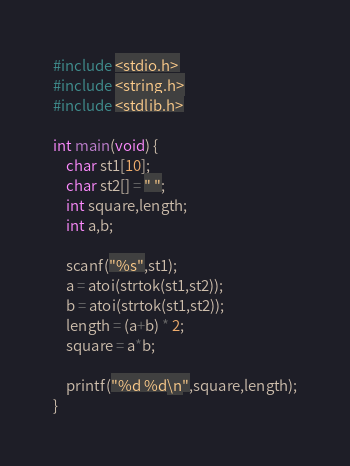Convert code to text. <code><loc_0><loc_0><loc_500><loc_500><_C_>#include <stdio.h>
#include <string.h>
#include <stdlib.h>

int main(void) {
	char st1[10];
	char st2[] = " ";
	int square,length;
	int a,b;
	
	scanf("%s",st1);
	a = atoi(strtok(st1,st2));
	b = atoi(strtok(st1,st2));
	length = (a+b) * 2;
	square = a*b;
	
	printf("%d %d\n",square,length);
}</code> 